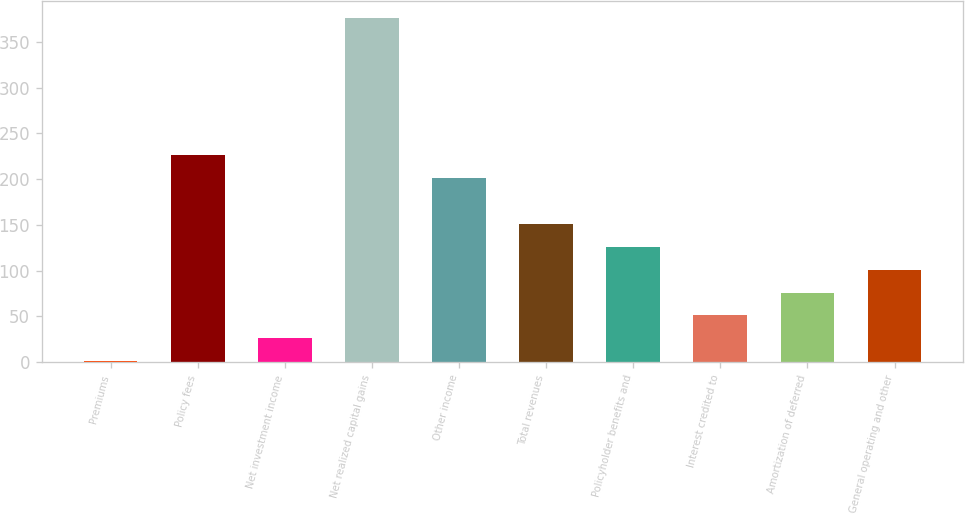<chart> <loc_0><loc_0><loc_500><loc_500><bar_chart><fcel>Premiums<fcel>Policy fees<fcel>Net investment income<fcel>Net realized capital gains<fcel>Other income<fcel>Total revenues<fcel>Policyholder benefits and<fcel>Interest credited to<fcel>Amortization of deferred<fcel>General operating and other<nl><fcel>1<fcel>226<fcel>26<fcel>376<fcel>201<fcel>151<fcel>126<fcel>51<fcel>76<fcel>101<nl></chart> 